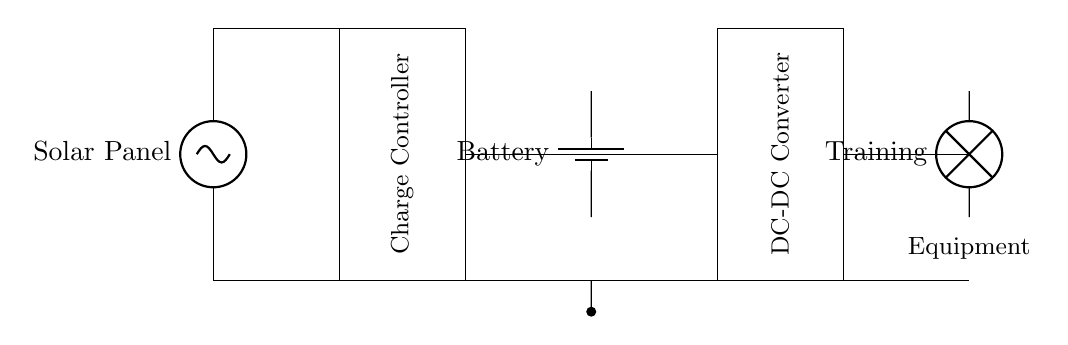What component converts solar energy into electrical energy? The solar panel in the circuit diagram converts solar energy into electrical energy, which is indicated by its label on the diagram.
Answer: Solar Panel What is the purpose of the charge controller? The charge controller regulates the voltage and current coming from the solar panel to the battery, ensuring the battery is charged safely and preventing overcharging.
Answer: Regulate charging Where does the electrical energy go after the battery? After the battery, electrical energy is sent to the DC-DC converter, which adjusts the voltage to the required level for the load. This flow is indicated by the connections shown in the diagram.
Answer: DC-DC Converter What does the training equipment represent in the circuit? The training equipment is represented by the lamp symbol, indicating it is the load that utilizes power from the battery, as labeled clearly in the diagram.
Answer: Training Equipment How many main components are connected to the solar panel? There are two main components connected to the solar panel: the charge controller and the battery. This can be seen from the connections leading from the solar panel in the diagram.
Answer: Two What is the function of a DC-DC converter in this circuit? The DC-DC converter functions to change the level of voltage supplied to the training equipment, ensuring it receives the appropriate voltage required for operation from the battery.
Answer: Voltage adjustment How does the circuit allow for sustainable energy use during training? The circuit utilizes a solar panel that captures sunlight, converts it to electricity, stores it in a battery, and delivers it to the training equipment, promoting sustainable energy use.
Answer: Solar energy 